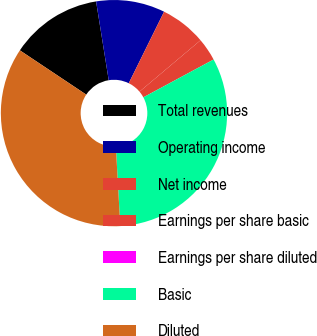<chart> <loc_0><loc_0><loc_500><loc_500><pie_chart><fcel>Total revenues<fcel>Operating income<fcel>Net income<fcel>Earnings per share basic<fcel>Earnings per share diluted<fcel>Basic<fcel>Diluted<nl><fcel>13.11%<fcel>9.83%<fcel>6.56%<fcel>3.28%<fcel>0.0%<fcel>31.97%<fcel>35.25%<nl></chart> 